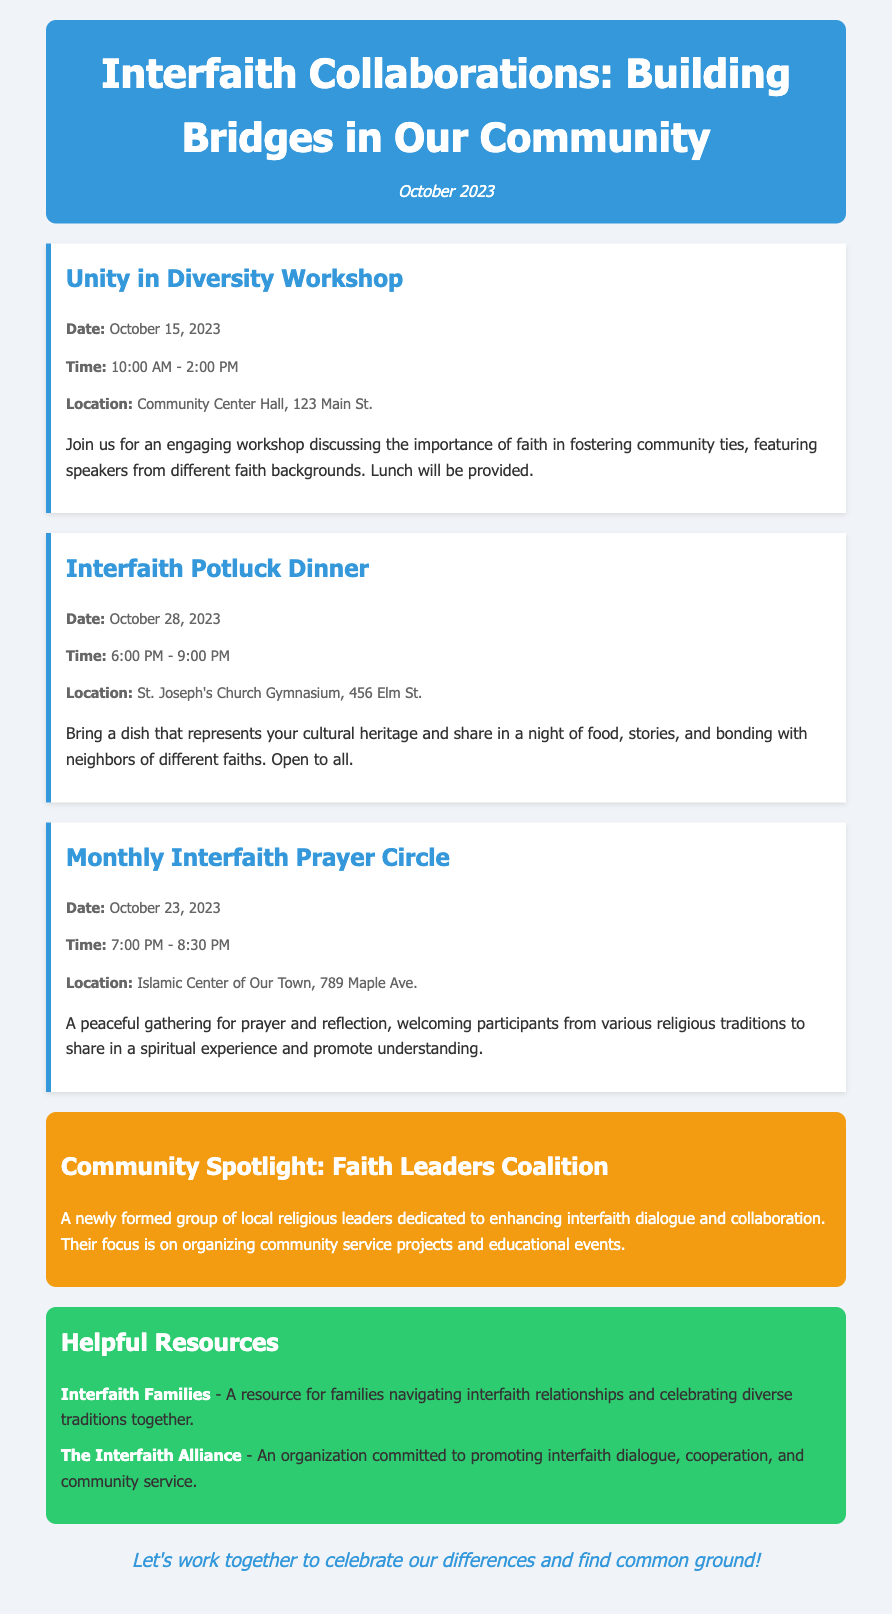What is the title of the newsletter? The title is prominently presented at the top of the document, reading "Interfaith Collaborations: Building Bridges in Our Community."
Answer: Interfaith Collaborations: Building Bridges in Our Community What is the date of the Unity in Diversity Workshop? This date can be found in the event details section of the workshop, which states "October 15, 2023."
Answer: October 15, 2023 What location hosts the Interfaith Potluck Dinner? The location for this dinner can be found in the event details, which states "St. Joseph's Church Gymnasium, 456 Elm St."
Answer: St. Joseph's Church Gymnasium, 456 Elm St How long is the Monthly Interfaith Prayer Circle scheduled for? The time for the Monthly Interfaith Prayer Circle is indicated as "7:00 PM - 8:30 PM," allowing for the calculation of the duration which is 1.5 hours.
Answer: 1.5 hours What is the main focus of the Faith Leaders Coalition? The spotlight section specifies their focus on "organizing community service projects and educational events."
Answer: Organizing community service projects and educational events Which organization is dedicated to promoting interfaith dialogue? One helpful resource mentioned in the document is the organization known as "The Interfaith Alliance."
Answer: The Interfaith Alliance What is the overall message conveyed at the end of the newsletter? The concluding message emphasizes unity and collaboration, stating: "Let's work together to celebrate our differences and find common ground!"
Answer: Let's work together to celebrate our differences and find common ground! What type of event is the October 28, 2023, gathering? The document describes this gathering as an "Interfaith Potluck Dinner."
Answer: Interfaith Potluck Dinner 